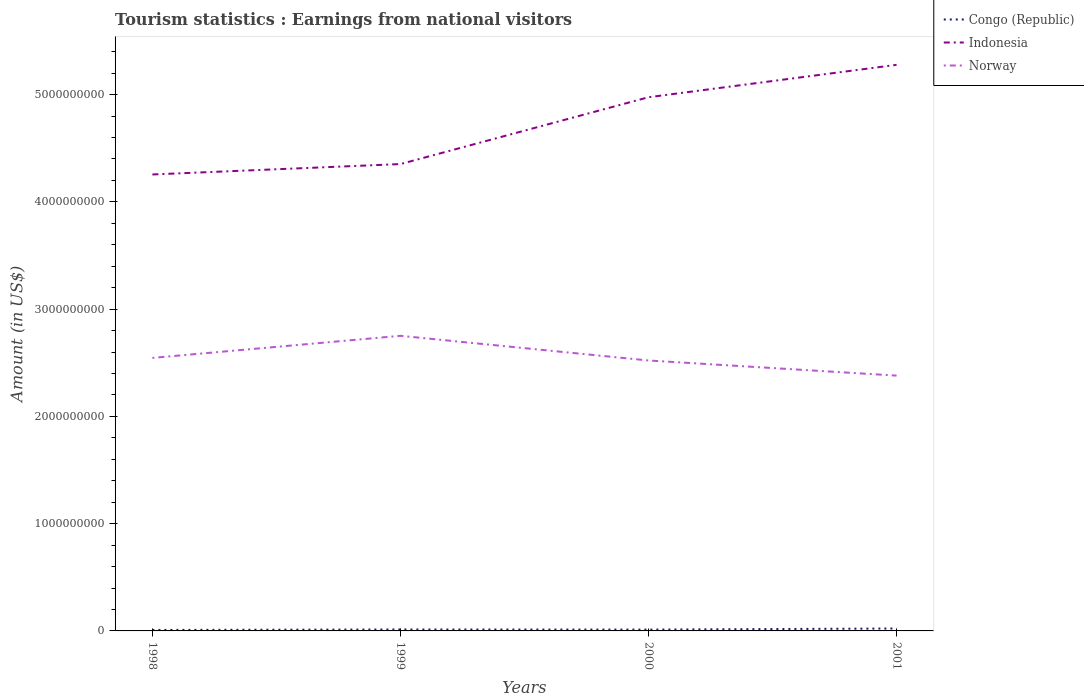How many different coloured lines are there?
Your response must be concise. 3. Across all years, what is the maximum earnings from national visitors in Norway?
Offer a terse response. 2.38e+09. In which year was the earnings from national visitors in Indonesia maximum?
Give a very brief answer. 1998. What is the total earnings from national visitors in Norway in the graph?
Make the answer very short. 2.30e+08. What is the difference between the highest and the second highest earnings from national visitors in Norway?
Provide a short and direct response. 3.71e+08. How many years are there in the graph?
Make the answer very short. 4. What is the difference between two consecutive major ticks on the Y-axis?
Offer a very short reply. 1.00e+09. Are the values on the major ticks of Y-axis written in scientific E-notation?
Provide a short and direct response. No. Does the graph contain any zero values?
Make the answer very short. No. How are the legend labels stacked?
Provide a succinct answer. Vertical. What is the title of the graph?
Your answer should be very brief. Tourism statistics : Earnings from national visitors. Does "Cayman Islands" appear as one of the legend labels in the graph?
Ensure brevity in your answer.  No. What is the label or title of the Y-axis?
Your response must be concise. Amount (in US$). What is the Amount (in US$) in Congo (Republic) in 1998?
Ensure brevity in your answer.  9.00e+06. What is the Amount (in US$) in Indonesia in 1998?
Make the answer very short. 4.26e+09. What is the Amount (in US$) of Norway in 1998?
Provide a short and direct response. 2.54e+09. What is the Amount (in US$) of Congo (Republic) in 1999?
Provide a succinct answer. 1.35e+07. What is the Amount (in US$) in Indonesia in 1999?
Your answer should be very brief. 4.35e+09. What is the Amount (in US$) of Norway in 1999?
Your answer should be very brief. 2.75e+09. What is the Amount (in US$) of Congo (Republic) in 2000?
Your answer should be compact. 1.24e+07. What is the Amount (in US$) of Indonesia in 2000?
Keep it short and to the point. 4.98e+09. What is the Amount (in US$) in Norway in 2000?
Keep it short and to the point. 2.52e+09. What is the Amount (in US$) of Congo (Republic) in 2001?
Ensure brevity in your answer.  2.26e+07. What is the Amount (in US$) in Indonesia in 2001?
Ensure brevity in your answer.  5.28e+09. What is the Amount (in US$) in Norway in 2001?
Make the answer very short. 2.38e+09. Across all years, what is the maximum Amount (in US$) in Congo (Republic)?
Your answer should be compact. 2.26e+07. Across all years, what is the maximum Amount (in US$) in Indonesia?
Give a very brief answer. 5.28e+09. Across all years, what is the maximum Amount (in US$) in Norway?
Give a very brief answer. 2.75e+09. Across all years, what is the minimum Amount (in US$) in Congo (Republic)?
Make the answer very short. 9.00e+06. Across all years, what is the minimum Amount (in US$) of Indonesia?
Ensure brevity in your answer.  4.26e+09. Across all years, what is the minimum Amount (in US$) of Norway?
Keep it short and to the point. 2.38e+09. What is the total Amount (in US$) of Congo (Republic) in the graph?
Offer a very short reply. 5.75e+07. What is the total Amount (in US$) of Indonesia in the graph?
Keep it short and to the point. 1.89e+1. What is the total Amount (in US$) of Norway in the graph?
Your response must be concise. 1.02e+1. What is the difference between the Amount (in US$) of Congo (Republic) in 1998 and that in 1999?
Your response must be concise. -4.50e+06. What is the difference between the Amount (in US$) of Indonesia in 1998 and that in 1999?
Give a very brief answer. -9.70e+07. What is the difference between the Amount (in US$) in Norway in 1998 and that in 1999?
Provide a succinct answer. -2.06e+08. What is the difference between the Amount (in US$) of Congo (Republic) in 1998 and that in 2000?
Your response must be concise. -3.40e+06. What is the difference between the Amount (in US$) of Indonesia in 1998 and that in 2000?
Offer a very short reply. -7.20e+08. What is the difference between the Amount (in US$) in Norway in 1998 and that in 2000?
Your response must be concise. 2.40e+07. What is the difference between the Amount (in US$) in Congo (Republic) in 1998 and that in 2001?
Keep it short and to the point. -1.36e+07. What is the difference between the Amount (in US$) in Indonesia in 1998 and that in 2001?
Ensure brevity in your answer.  -1.02e+09. What is the difference between the Amount (in US$) of Norway in 1998 and that in 2001?
Offer a very short reply. 1.65e+08. What is the difference between the Amount (in US$) of Congo (Republic) in 1999 and that in 2000?
Your response must be concise. 1.10e+06. What is the difference between the Amount (in US$) of Indonesia in 1999 and that in 2000?
Your response must be concise. -6.23e+08. What is the difference between the Amount (in US$) in Norway in 1999 and that in 2000?
Provide a short and direct response. 2.30e+08. What is the difference between the Amount (in US$) in Congo (Republic) in 1999 and that in 2001?
Offer a very short reply. -9.10e+06. What is the difference between the Amount (in US$) in Indonesia in 1999 and that in 2001?
Your answer should be compact. -9.25e+08. What is the difference between the Amount (in US$) of Norway in 1999 and that in 2001?
Provide a short and direct response. 3.71e+08. What is the difference between the Amount (in US$) in Congo (Republic) in 2000 and that in 2001?
Keep it short and to the point. -1.02e+07. What is the difference between the Amount (in US$) in Indonesia in 2000 and that in 2001?
Your response must be concise. -3.02e+08. What is the difference between the Amount (in US$) of Norway in 2000 and that in 2001?
Offer a very short reply. 1.41e+08. What is the difference between the Amount (in US$) of Congo (Republic) in 1998 and the Amount (in US$) of Indonesia in 1999?
Offer a very short reply. -4.34e+09. What is the difference between the Amount (in US$) of Congo (Republic) in 1998 and the Amount (in US$) of Norway in 1999?
Give a very brief answer. -2.74e+09. What is the difference between the Amount (in US$) of Indonesia in 1998 and the Amount (in US$) of Norway in 1999?
Keep it short and to the point. 1.50e+09. What is the difference between the Amount (in US$) in Congo (Republic) in 1998 and the Amount (in US$) in Indonesia in 2000?
Your response must be concise. -4.97e+09. What is the difference between the Amount (in US$) in Congo (Republic) in 1998 and the Amount (in US$) in Norway in 2000?
Ensure brevity in your answer.  -2.51e+09. What is the difference between the Amount (in US$) of Indonesia in 1998 and the Amount (in US$) of Norway in 2000?
Ensure brevity in your answer.  1.73e+09. What is the difference between the Amount (in US$) in Congo (Republic) in 1998 and the Amount (in US$) in Indonesia in 2001?
Offer a very short reply. -5.27e+09. What is the difference between the Amount (in US$) of Congo (Republic) in 1998 and the Amount (in US$) of Norway in 2001?
Offer a terse response. -2.37e+09. What is the difference between the Amount (in US$) in Indonesia in 1998 and the Amount (in US$) in Norway in 2001?
Provide a short and direct response. 1.88e+09. What is the difference between the Amount (in US$) of Congo (Republic) in 1999 and the Amount (in US$) of Indonesia in 2000?
Offer a very short reply. -4.96e+09. What is the difference between the Amount (in US$) in Congo (Republic) in 1999 and the Amount (in US$) in Norway in 2000?
Your answer should be very brief. -2.51e+09. What is the difference between the Amount (in US$) of Indonesia in 1999 and the Amount (in US$) of Norway in 2000?
Your answer should be compact. 1.83e+09. What is the difference between the Amount (in US$) in Congo (Republic) in 1999 and the Amount (in US$) in Indonesia in 2001?
Give a very brief answer. -5.26e+09. What is the difference between the Amount (in US$) in Congo (Republic) in 1999 and the Amount (in US$) in Norway in 2001?
Offer a very short reply. -2.37e+09. What is the difference between the Amount (in US$) of Indonesia in 1999 and the Amount (in US$) of Norway in 2001?
Provide a short and direct response. 1.97e+09. What is the difference between the Amount (in US$) in Congo (Republic) in 2000 and the Amount (in US$) in Indonesia in 2001?
Give a very brief answer. -5.26e+09. What is the difference between the Amount (in US$) in Congo (Republic) in 2000 and the Amount (in US$) in Norway in 2001?
Make the answer very short. -2.37e+09. What is the difference between the Amount (in US$) of Indonesia in 2000 and the Amount (in US$) of Norway in 2001?
Offer a terse response. 2.60e+09. What is the average Amount (in US$) of Congo (Republic) per year?
Ensure brevity in your answer.  1.44e+07. What is the average Amount (in US$) of Indonesia per year?
Ensure brevity in your answer.  4.71e+09. What is the average Amount (in US$) of Norway per year?
Offer a terse response. 2.55e+09. In the year 1998, what is the difference between the Amount (in US$) in Congo (Republic) and Amount (in US$) in Indonesia?
Give a very brief answer. -4.25e+09. In the year 1998, what is the difference between the Amount (in US$) of Congo (Republic) and Amount (in US$) of Norway?
Your answer should be very brief. -2.54e+09. In the year 1998, what is the difference between the Amount (in US$) in Indonesia and Amount (in US$) in Norway?
Your response must be concise. 1.71e+09. In the year 1999, what is the difference between the Amount (in US$) in Congo (Republic) and Amount (in US$) in Indonesia?
Keep it short and to the point. -4.34e+09. In the year 1999, what is the difference between the Amount (in US$) of Congo (Republic) and Amount (in US$) of Norway?
Ensure brevity in your answer.  -2.74e+09. In the year 1999, what is the difference between the Amount (in US$) of Indonesia and Amount (in US$) of Norway?
Provide a succinct answer. 1.60e+09. In the year 2000, what is the difference between the Amount (in US$) in Congo (Republic) and Amount (in US$) in Indonesia?
Your response must be concise. -4.96e+09. In the year 2000, what is the difference between the Amount (in US$) of Congo (Republic) and Amount (in US$) of Norway?
Ensure brevity in your answer.  -2.51e+09. In the year 2000, what is the difference between the Amount (in US$) in Indonesia and Amount (in US$) in Norway?
Your response must be concise. 2.45e+09. In the year 2001, what is the difference between the Amount (in US$) in Congo (Republic) and Amount (in US$) in Indonesia?
Ensure brevity in your answer.  -5.25e+09. In the year 2001, what is the difference between the Amount (in US$) of Congo (Republic) and Amount (in US$) of Norway?
Ensure brevity in your answer.  -2.36e+09. In the year 2001, what is the difference between the Amount (in US$) of Indonesia and Amount (in US$) of Norway?
Provide a short and direct response. 2.90e+09. What is the ratio of the Amount (in US$) of Indonesia in 1998 to that in 1999?
Provide a succinct answer. 0.98. What is the ratio of the Amount (in US$) of Norway in 1998 to that in 1999?
Keep it short and to the point. 0.93. What is the ratio of the Amount (in US$) in Congo (Republic) in 1998 to that in 2000?
Give a very brief answer. 0.73. What is the ratio of the Amount (in US$) in Indonesia in 1998 to that in 2000?
Ensure brevity in your answer.  0.86. What is the ratio of the Amount (in US$) in Norway in 1998 to that in 2000?
Ensure brevity in your answer.  1.01. What is the ratio of the Amount (in US$) in Congo (Republic) in 1998 to that in 2001?
Make the answer very short. 0.4. What is the ratio of the Amount (in US$) in Indonesia in 1998 to that in 2001?
Give a very brief answer. 0.81. What is the ratio of the Amount (in US$) in Norway in 1998 to that in 2001?
Keep it short and to the point. 1.07. What is the ratio of the Amount (in US$) in Congo (Republic) in 1999 to that in 2000?
Your answer should be compact. 1.09. What is the ratio of the Amount (in US$) of Indonesia in 1999 to that in 2000?
Keep it short and to the point. 0.87. What is the ratio of the Amount (in US$) of Norway in 1999 to that in 2000?
Give a very brief answer. 1.09. What is the ratio of the Amount (in US$) of Congo (Republic) in 1999 to that in 2001?
Your response must be concise. 0.6. What is the ratio of the Amount (in US$) of Indonesia in 1999 to that in 2001?
Offer a very short reply. 0.82. What is the ratio of the Amount (in US$) in Norway in 1999 to that in 2001?
Make the answer very short. 1.16. What is the ratio of the Amount (in US$) of Congo (Republic) in 2000 to that in 2001?
Your answer should be compact. 0.55. What is the ratio of the Amount (in US$) in Indonesia in 2000 to that in 2001?
Provide a succinct answer. 0.94. What is the ratio of the Amount (in US$) of Norway in 2000 to that in 2001?
Give a very brief answer. 1.06. What is the difference between the highest and the second highest Amount (in US$) in Congo (Republic)?
Provide a succinct answer. 9.10e+06. What is the difference between the highest and the second highest Amount (in US$) of Indonesia?
Provide a short and direct response. 3.02e+08. What is the difference between the highest and the second highest Amount (in US$) in Norway?
Provide a succinct answer. 2.06e+08. What is the difference between the highest and the lowest Amount (in US$) of Congo (Republic)?
Keep it short and to the point. 1.36e+07. What is the difference between the highest and the lowest Amount (in US$) of Indonesia?
Your response must be concise. 1.02e+09. What is the difference between the highest and the lowest Amount (in US$) of Norway?
Offer a very short reply. 3.71e+08. 